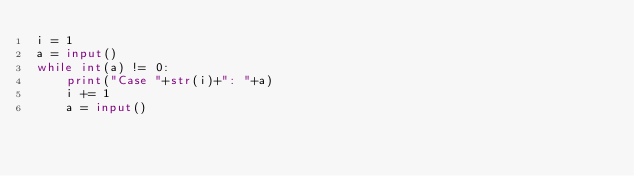Convert code to text. <code><loc_0><loc_0><loc_500><loc_500><_Python_>i = 1
a = input()
while int(a) != 0:
    print("Case "+str(i)+": "+a)
    i += 1
    a = input()</code> 